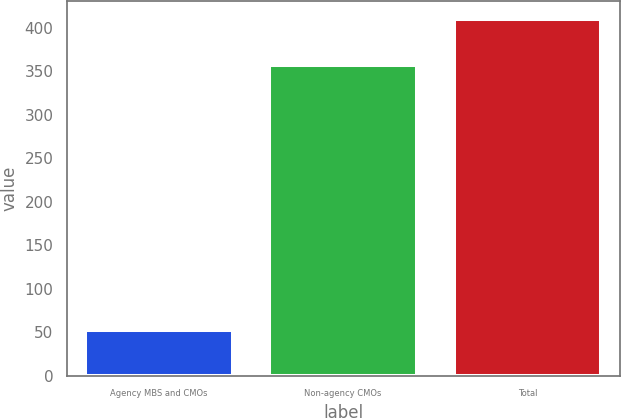<chart> <loc_0><loc_0><loc_500><loc_500><bar_chart><fcel>Agency MBS and CMOs<fcel>Non-agency CMOs<fcel>Total<nl><fcel>53<fcel>357<fcel>410<nl></chart> 